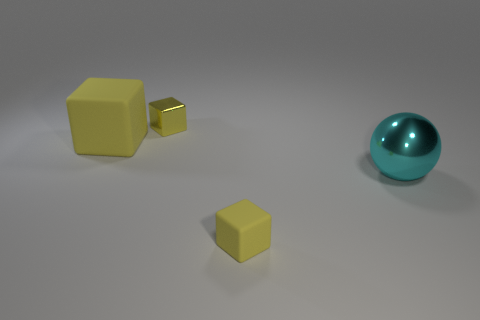Do the cyan shiny sphere and the matte object that is behind the sphere have the same size?
Give a very brief answer. Yes. There is a tiny yellow object that is behind the big cyan thing; what is its shape?
Offer a terse response. Cube. Is the number of yellow matte blocks that are right of the tiny yellow metal cube greater than the number of large matte balls?
Offer a terse response. Yes. What number of small matte cubes are to the left of the large object that is to the left of the rubber thing that is to the right of the metallic block?
Offer a terse response. 0. There is a yellow thing that is left of the small metallic cube; is it the same size as the matte block that is in front of the large metal object?
Your answer should be very brief. No. What material is the large yellow object that is behind the tiny yellow cube in front of the cyan metal object?
Offer a terse response. Rubber. How many things are things on the left side of the tiny shiny cube or small red matte things?
Keep it short and to the point. 1. Are there an equal number of blocks on the left side of the small shiny thing and big yellow rubber cubes right of the big cyan ball?
Make the answer very short. No. The small yellow thing that is right of the small yellow object to the left of the matte object on the right side of the tiny metallic object is made of what material?
Provide a short and direct response. Rubber. What is the size of the object that is right of the shiny cube and to the left of the large cyan object?
Ensure brevity in your answer.  Small. 